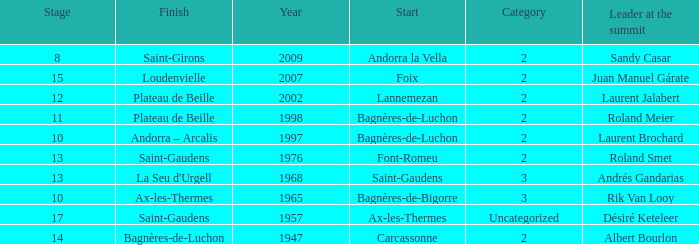Give the Finish for a Stage that is larger than 15 Saint-Gaudens. 